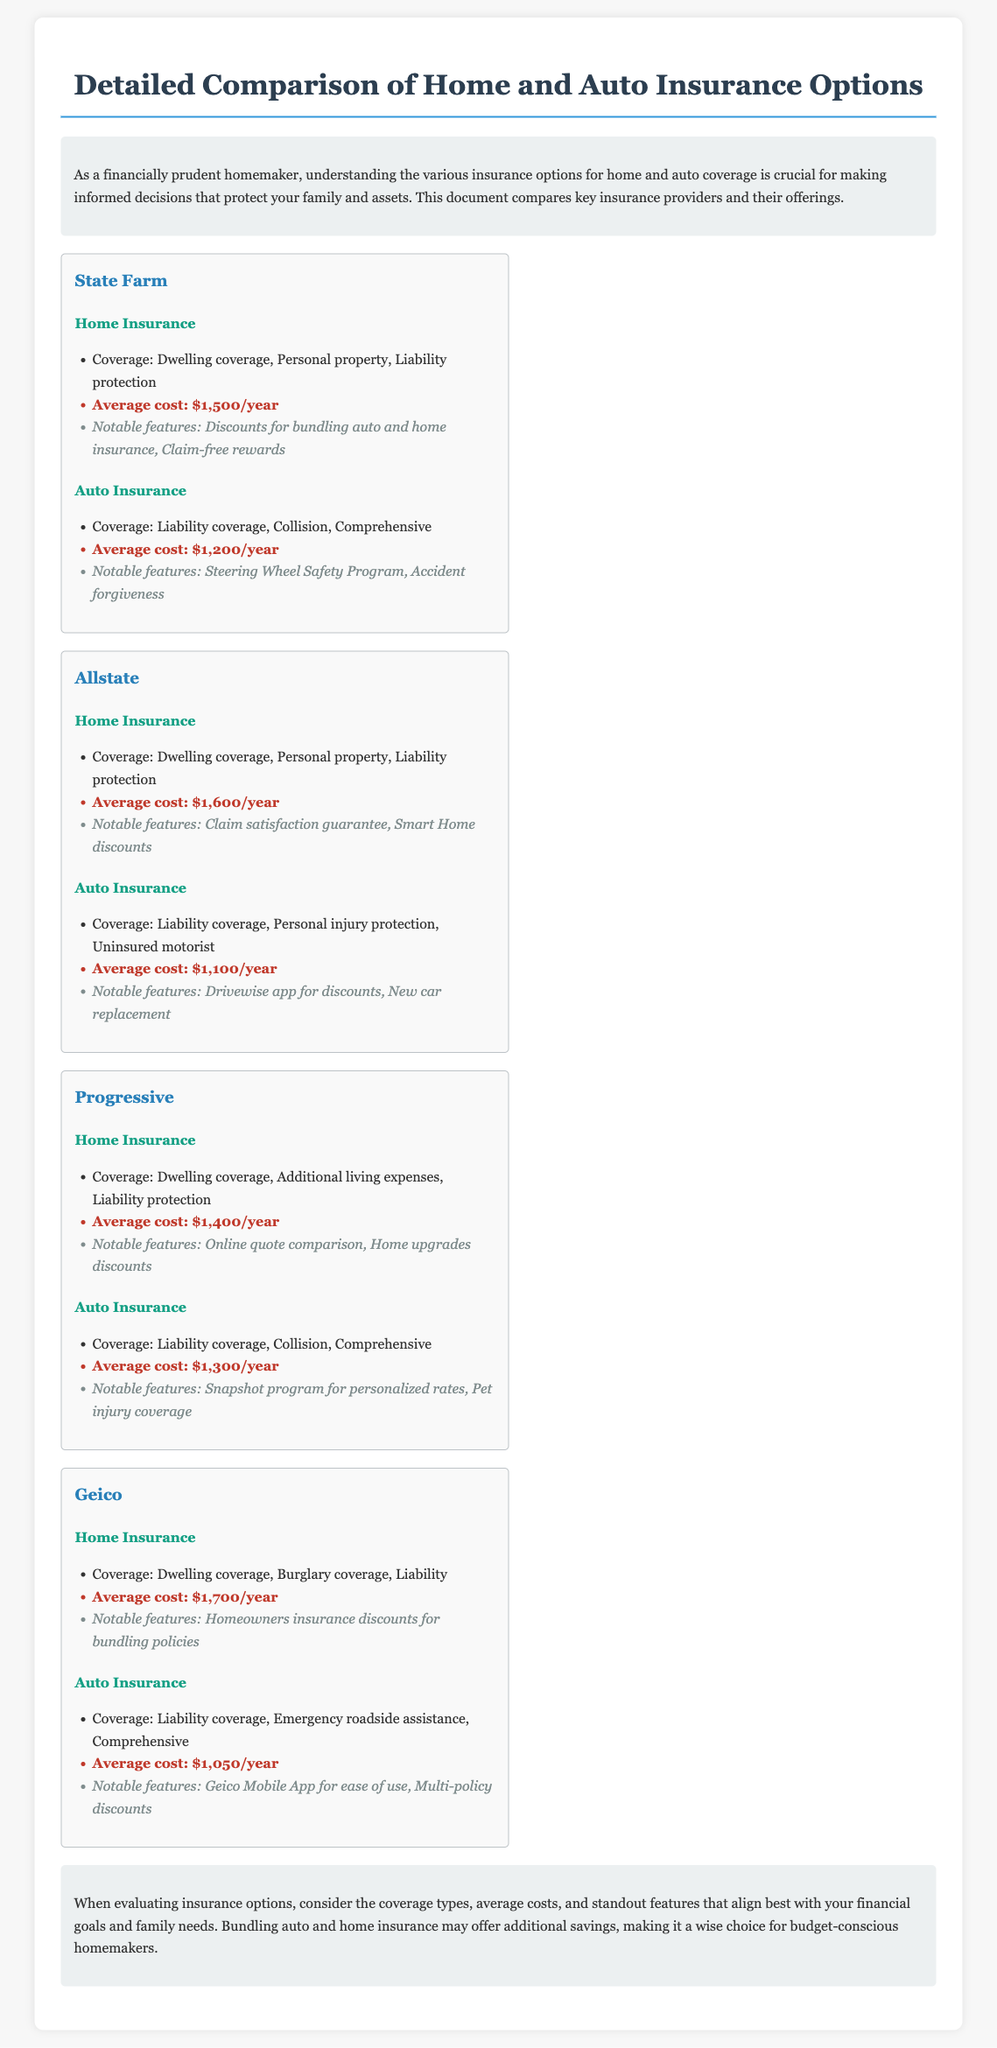What is the average cost of State Farm home insurance? The document states that State Farm's average cost for home insurance is $1,500 per year.
Answer: $1,500/year What notable feature does Allstate offer for home insurance? The document lists that Allstate provides a claim satisfaction guarantee as a notable feature.
Answer: Claim satisfaction guarantee What is the average cost of Geico auto insurance? According to the document, Geico's average cost for auto insurance is $1,050 per year.
Answer: $1,050/year What type of coverage is included in Progressive's home insurance? The document mentions that Progressive's home insurance includes dwelling coverage, additional living expenses, and liability protection.
Answer: Dwelling coverage, additional living expenses, liability protection What is a common notable feature for both State Farm and Progressive auto insurance? The document states that both providers feature programs aimed at rewarding safe driving: State Farm has the Steering Wheel Safety Program, and Progressive has the Snapshot program.
Answer: Steering Wheel Safety Program and Snapshot program What insurance options can lead to discounts by bundling? The document mentions that bundling home and auto insurance can lead to additional savings.
Answer: Home and auto insurance bundling 